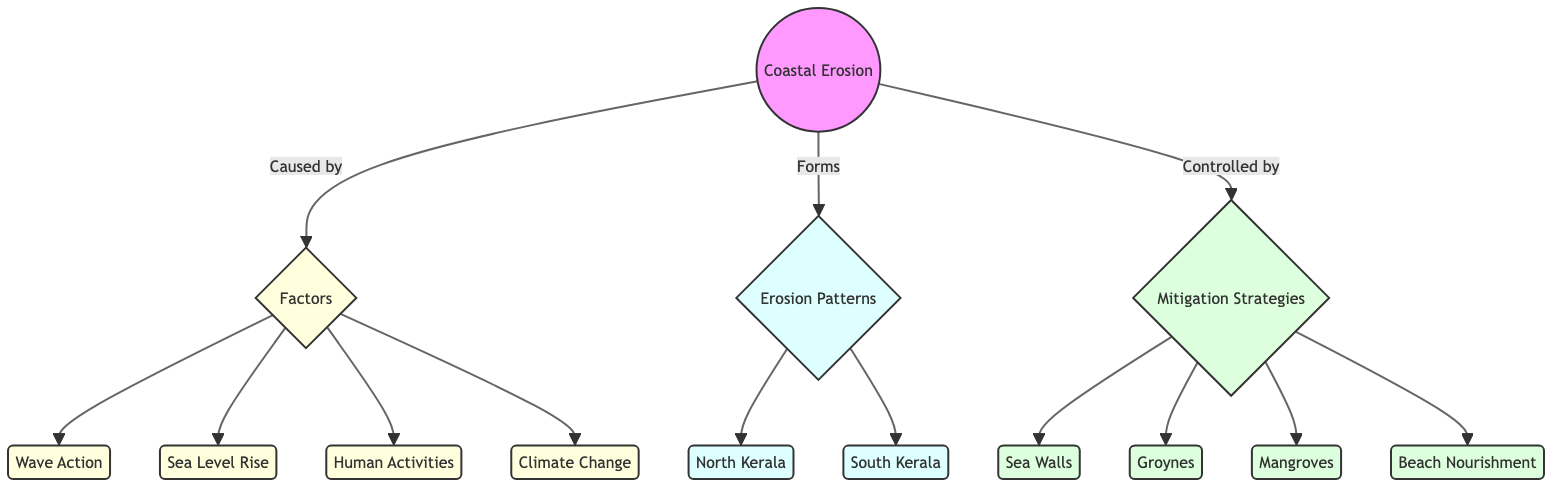What are the two main regions affected by coastal erosion? The diagram lists two geographic areas under "Erosion Patterns": North Kerala and South Kerala. These regions represent the two primary locations mentioned in the context of coastal erosion along the Kerala coastline.
Answer: North Kerala, South Kerala Which factor is associated with "Wave Action"? From the diagram, "Wave Action" is a specific node connected to the larger category "Factors," which implies it's one of the main contributors to coastal erosion.
Answer: Wave Action How many mitigation strategies are indicated in the diagram? The diagram identifies four nodes under "Mitigation Strategies": Sea Walls, Groynes, Mangroves, and Beach Nourishment. By counting these nodes, we can determine the total number of strategies available.
Answer: 4 What is one of the human activities contributing to coastal erosion? The diagram correctly identifies "Human Activities" as a factor leading to coastal erosion. This term encompasses various specific practices that can impact coastal environments negatively.
Answer: Human Activities Which factors are considered causes of coastal erosion? The diagram details four distinct factors that lead to coastal erosion: Wave Action, Sea Level Rise, Human Activities, and Climate Change. All four are interconnected under the "Factors" node in the diagram.
Answer: Wave Action, Sea Level Rise, Human Activities, Climate Change How are mitigation strategies related to coastal erosion? The diagram illustrates that mitigation strategies are implemented to control coastal erosion. The arrow pointing from "Mitigation Strategies" to "Coastal Erosion" signifies this relationship, emphasizing the role strategies play in managing erosive processes.
Answer: Controlled by mitigation strategies What main strategy is focused on replenishing beaches? In the diagram, "Beach Nourishment" is categorized as a mitigation strategy specifically designed to combat erosion by adding sand to coastal areas, which directly addresses the issue of beach loss.
Answer: Beach Nourishment What causes are associated with climate change in the diagram? The diagram includes "Climate Change" as one of the four factors under "Factors." This indicates that climate change is linked to processes that contribute to coastal erosion but does not explicitly detail individual causes within that factor.
Answer: Climate Change 